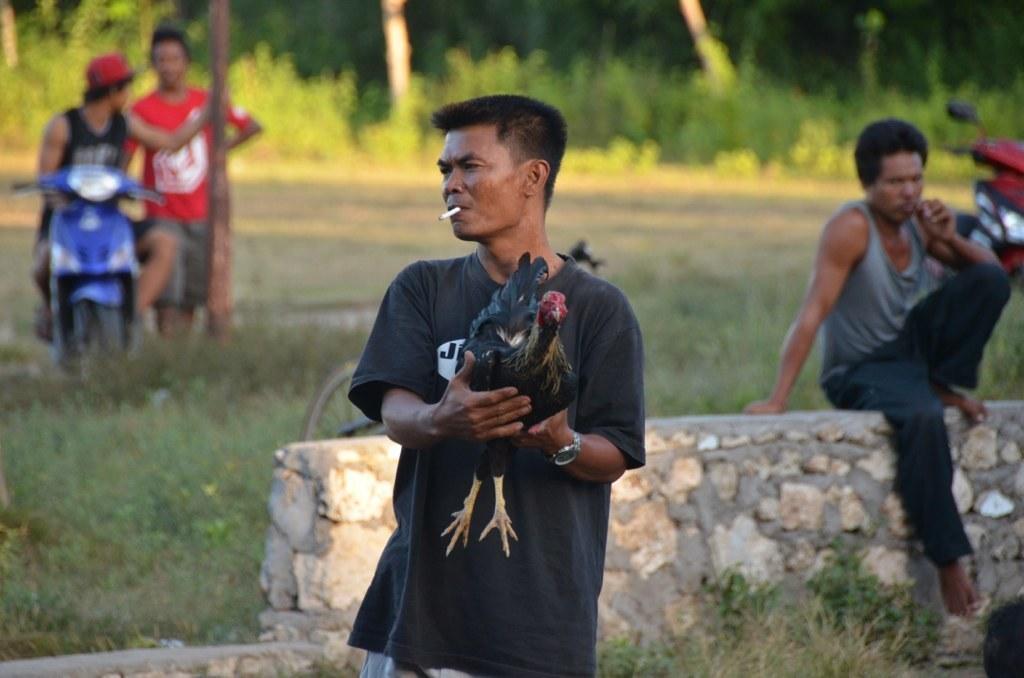Can you describe this image briefly? In this picture I can see there is a man standing and he is wearing a black shirt, a watch and he is smoking and he is holding a black hen in his hand. In the backdrop on the right of the image there is a person sitting on the wall and there is a two wheeler parked behind him. On the left there are two persons, one of them is sitting on the two wheeler, wearing a black shirt with red cap and the other is standing beside him is wearing a red shirt and there are plants and trees in the backdrop. 